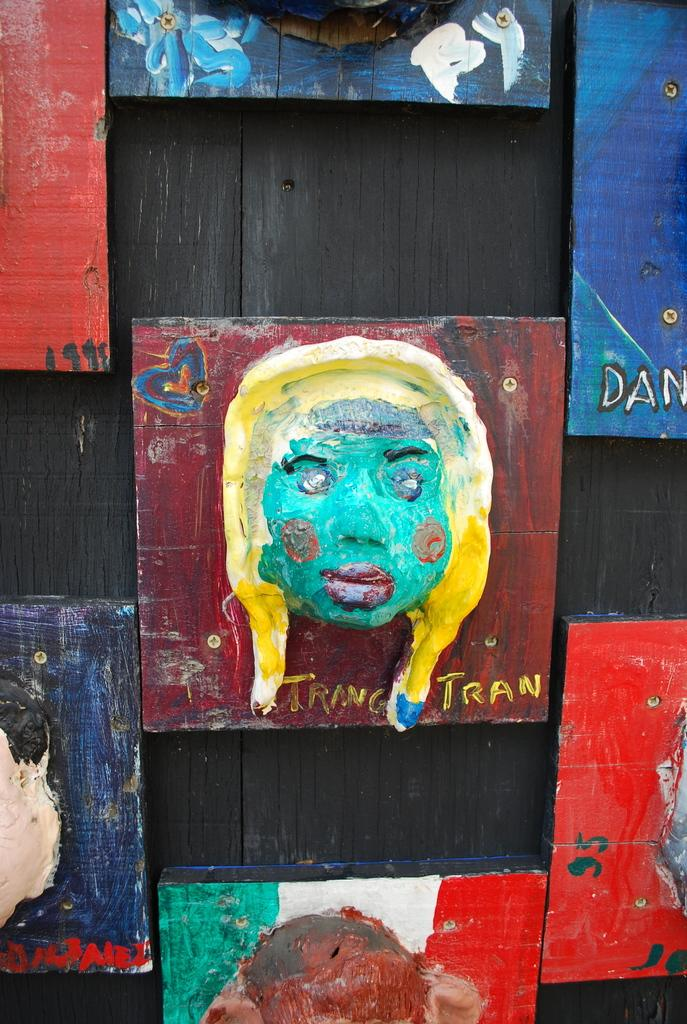What color is the wall in the image? The wall in the image is black. What is displayed on the wall? There are many paintings on the wall. Where is the kitty playing with the oil in the image? There is no kitty or oil present in the image. 